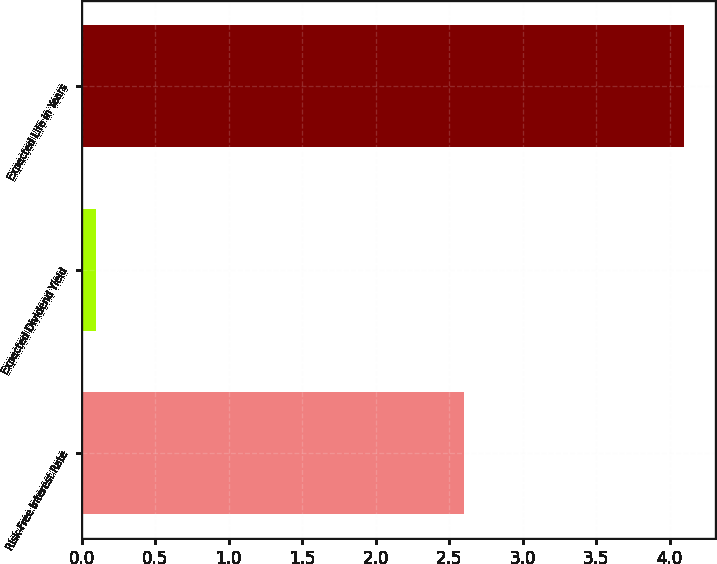Convert chart. <chart><loc_0><loc_0><loc_500><loc_500><bar_chart><fcel>Risk-Free Interest Rate<fcel>Expected Dividend Yield<fcel>Expected Life in Years<nl><fcel>2.6<fcel>0.1<fcel>4.1<nl></chart> 